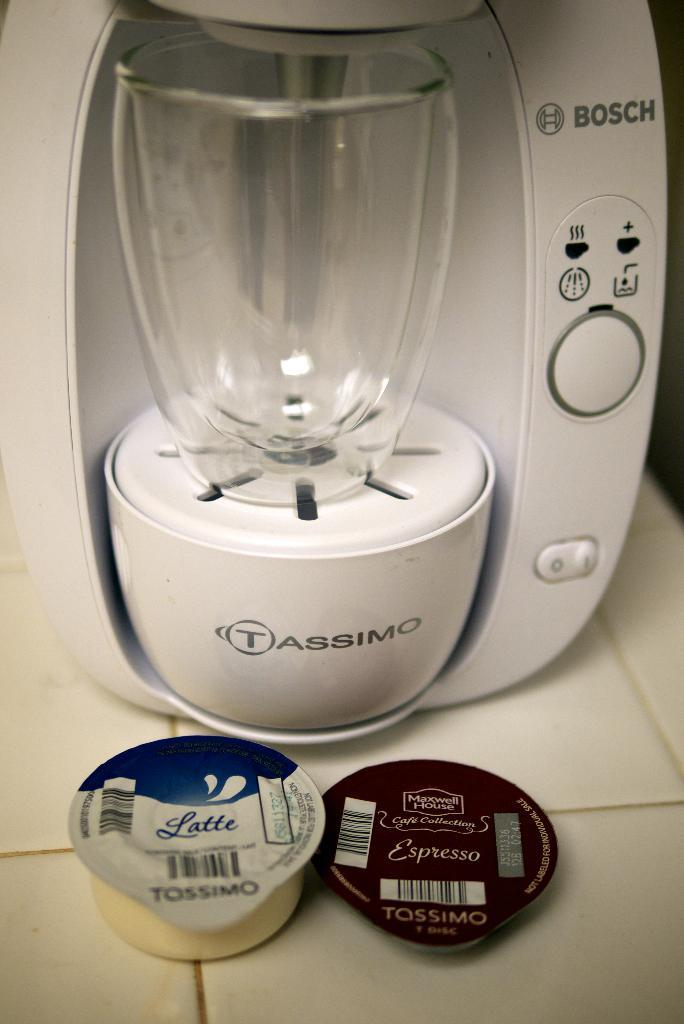<image>
Write a terse but informative summary of the picture. a drink maker with the 'bosch' name brand labeled on it 